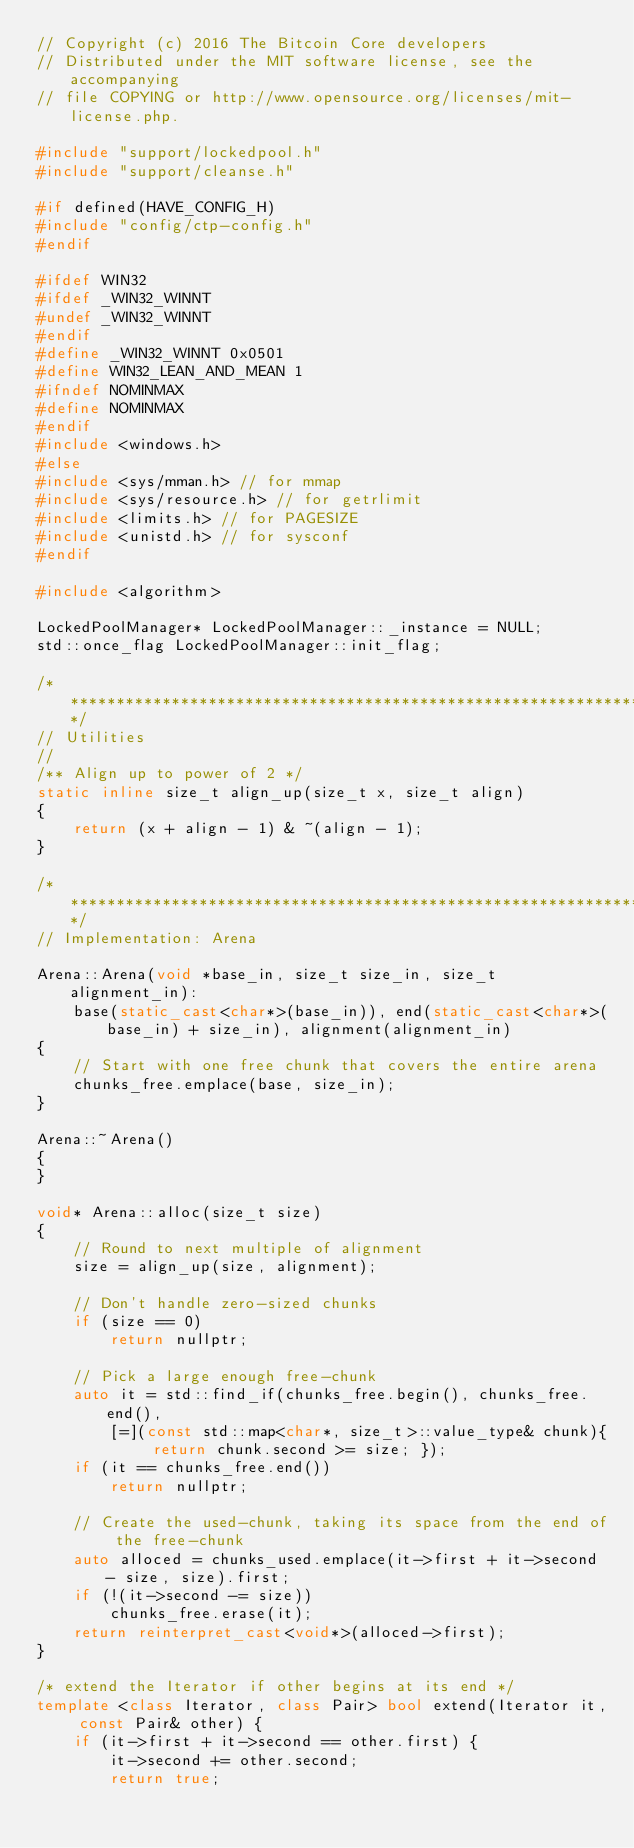<code> <loc_0><loc_0><loc_500><loc_500><_C++_>// Copyright (c) 2016 The Bitcoin Core developers
// Distributed under the MIT software license, see the accompanying
// file COPYING or http://www.opensource.org/licenses/mit-license.php.

#include "support/lockedpool.h"
#include "support/cleanse.h"

#if defined(HAVE_CONFIG_H)
#include "config/ctp-config.h"
#endif

#ifdef WIN32
#ifdef _WIN32_WINNT
#undef _WIN32_WINNT
#endif
#define _WIN32_WINNT 0x0501
#define WIN32_LEAN_AND_MEAN 1
#ifndef NOMINMAX
#define NOMINMAX
#endif
#include <windows.h>
#else
#include <sys/mman.h> // for mmap
#include <sys/resource.h> // for getrlimit
#include <limits.h> // for PAGESIZE
#include <unistd.h> // for sysconf
#endif

#include <algorithm>

LockedPoolManager* LockedPoolManager::_instance = NULL;
std::once_flag LockedPoolManager::init_flag;

/*******************************************************************************/
// Utilities
//
/** Align up to power of 2 */
static inline size_t align_up(size_t x, size_t align)
{
    return (x + align - 1) & ~(align - 1);
}

/*******************************************************************************/
// Implementation: Arena

Arena::Arena(void *base_in, size_t size_in, size_t alignment_in):
    base(static_cast<char*>(base_in)), end(static_cast<char*>(base_in) + size_in), alignment(alignment_in)
{
    // Start with one free chunk that covers the entire arena
    chunks_free.emplace(base, size_in);
}

Arena::~Arena()
{
}

void* Arena::alloc(size_t size)
{
    // Round to next multiple of alignment
    size = align_up(size, alignment);

    // Don't handle zero-sized chunks
    if (size == 0)
        return nullptr;

    // Pick a large enough free-chunk
    auto it = std::find_if(chunks_free.begin(), chunks_free.end(),
        [=](const std::map<char*, size_t>::value_type& chunk){ return chunk.second >= size; });
    if (it == chunks_free.end())
        return nullptr;

    // Create the used-chunk, taking its space from the end of the free-chunk
    auto alloced = chunks_used.emplace(it->first + it->second - size, size).first;
    if (!(it->second -= size))
        chunks_free.erase(it);
    return reinterpret_cast<void*>(alloced->first);
}

/* extend the Iterator if other begins at its end */
template <class Iterator, class Pair> bool extend(Iterator it, const Pair& other) {
    if (it->first + it->second == other.first) {
        it->second += other.second;
        return true;</code> 